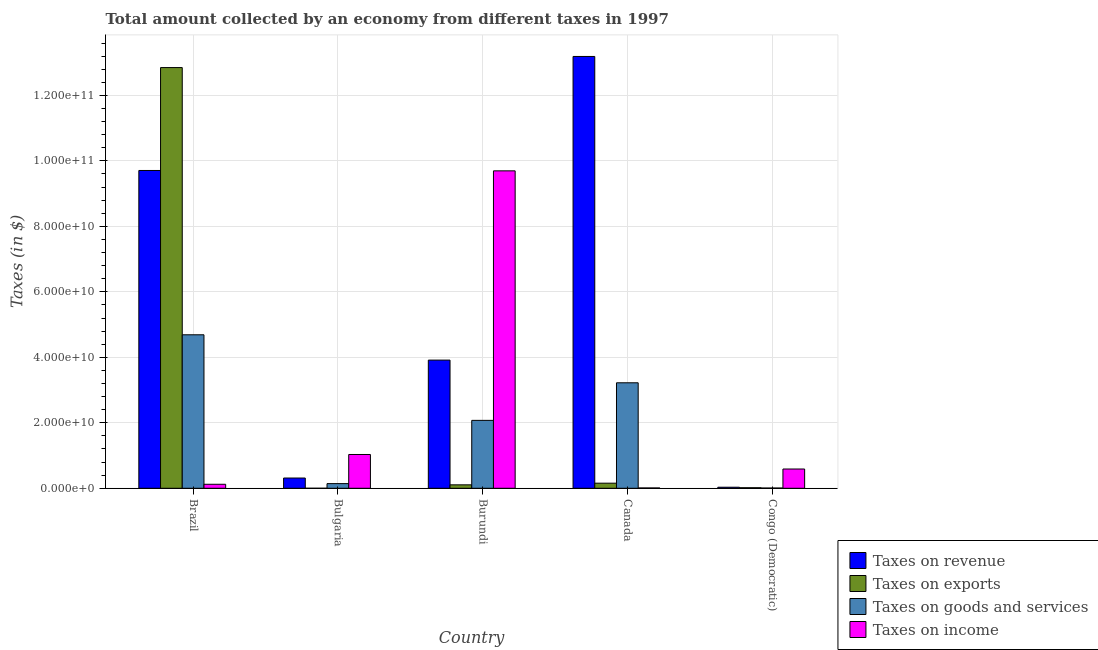How many different coloured bars are there?
Make the answer very short. 4. Are the number of bars per tick equal to the number of legend labels?
Your answer should be very brief. Yes. How many bars are there on the 4th tick from the right?
Your answer should be compact. 4. What is the label of the 5th group of bars from the left?
Offer a terse response. Congo (Democratic). What is the amount collected as tax on goods in Canada?
Offer a very short reply. 3.22e+1. Across all countries, what is the maximum amount collected as tax on revenue?
Your response must be concise. 1.32e+11. Across all countries, what is the minimum amount collected as tax on exports?
Make the answer very short. 2.00e+06. In which country was the amount collected as tax on goods minimum?
Offer a terse response. Congo (Democratic). What is the total amount collected as tax on goods in the graph?
Your answer should be compact. 1.01e+11. What is the difference between the amount collected as tax on goods in Bulgaria and that in Burundi?
Ensure brevity in your answer.  -1.93e+1. What is the difference between the amount collected as tax on exports in Canada and the amount collected as tax on revenue in Congo (Democratic)?
Offer a very short reply. 1.23e+09. What is the average amount collected as tax on goods per country?
Offer a terse response. 2.03e+1. What is the difference between the amount collected as tax on income and amount collected as tax on revenue in Bulgaria?
Ensure brevity in your answer.  7.19e+09. In how many countries, is the amount collected as tax on revenue greater than 124000000000 $?
Offer a terse response. 1. What is the ratio of the amount collected as tax on exports in Burundi to that in Congo (Democratic)?
Provide a short and direct response. 6.27. Is the amount collected as tax on goods in Brazil less than that in Congo (Democratic)?
Keep it short and to the point. No. What is the difference between the highest and the second highest amount collected as tax on revenue?
Provide a succinct answer. 3.48e+1. What is the difference between the highest and the lowest amount collected as tax on goods?
Keep it short and to the point. 4.68e+1. In how many countries, is the amount collected as tax on income greater than the average amount collected as tax on income taken over all countries?
Your answer should be very brief. 1. Is the sum of the amount collected as tax on income in Canada and Congo (Democratic) greater than the maximum amount collected as tax on goods across all countries?
Offer a very short reply. No. Is it the case that in every country, the sum of the amount collected as tax on revenue and amount collected as tax on goods is greater than the sum of amount collected as tax on exports and amount collected as tax on income?
Provide a succinct answer. No. What does the 2nd bar from the left in Canada represents?
Make the answer very short. Taxes on exports. What does the 3rd bar from the right in Bulgaria represents?
Make the answer very short. Taxes on exports. Is it the case that in every country, the sum of the amount collected as tax on revenue and amount collected as tax on exports is greater than the amount collected as tax on goods?
Your answer should be very brief. Yes. Does the graph contain any zero values?
Your answer should be compact. No. Does the graph contain grids?
Ensure brevity in your answer.  Yes. Where does the legend appear in the graph?
Keep it short and to the point. Bottom right. How many legend labels are there?
Your answer should be very brief. 4. What is the title of the graph?
Give a very brief answer. Total amount collected by an economy from different taxes in 1997. What is the label or title of the X-axis?
Keep it short and to the point. Country. What is the label or title of the Y-axis?
Your answer should be compact. Taxes (in $). What is the Taxes (in $) of Taxes on revenue in Brazil?
Offer a very short reply. 9.71e+1. What is the Taxes (in $) of Taxes on exports in Brazil?
Your answer should be very brief. 1.28e+11. What is the Taxes (in $) in Taxes on goods and services in Brazil?
Your response must be concise. 4.69e+1. What is the Taxes (in $) of Taxes on income in Brazil?
Make the answer very short. 1.22e+09. What is the Taxes (in $) of Taxes on revenue in Bulgaria?
Your response must be concise. 3.13e+09. What is the Taxes (in $) in Taxes on exports in Bulgaria?
Offer a very short reply. 2.00e+06. What is the Taxes (in $) of Taxes on goods and services in Bulgaria?
Give a very brief answer. 1.42e+09. What is the Taxes (in $) in Taxes on income in Bulgaria?
Your response must be concise. 1.03e+1. What is the Taxes (in $) of Taxes on revenue in Burundi?
Provide a short and direct response. 3.91e+1. What is the Taxes (in $) of Taxes on exports in Burundi?
Your answer should be compact. 1.05e+09. What is the Taxes (in $) of Taxes on goods and services in Burundi?
Offer a terse response. 2.07e+1. What is the Taxes (in $) of Taxes on income in Burundi?
Provide a short and direct response. 9.70e+1. What is the Taxes (in $) of Taxes on revenue in Canada?
Offer a terse response. 1.32e+11. What is the Taxes (in $) of Taxes on exports in Canada?
Make the answer very short. 1.56e+09. What is the Taxes (in $) in Taxes on goods and services in Canada?
Keep it short and to the point. 3.22e+1. What is the Taxes (in $) of Taxes on income in Canada?
Make the answer very short. 1.01e+08. What is the Taxes (in $) in Taxes on revenue in Congo (Democratic)?
Provide a short and direct response. 3.24e+08. What is the Taxes (in $) in Taxes on exports in Congo (Democratic)?
Make the answer very short. 1.68e+08. What is the Taxes (in $) in Taxes on goods and services in Congo (Democratic)?
Provide a succinct answer. 7.41e+07. What is the Taxes (in $) in Taxes on income in Congo (Democratic)?
Give a very brief answer. 5.89e+09. Across all countries, what is the maximum Taxes (in $) of Taxes on revenue?
Provide a short and direct response. 1.32e+11. Across all countries, what is the maximum Taxes (in $) of Taxes on exports?
Your answer should be very brief. 1.28e+11. Across all countries, what is the maximum Taxes (in $) in Taxes on goods and services?
Your answer should be compact. 4.69e+1. Across all countries, what is the maximum Taxes (in $) in Taxes on income?
Keep it short and to the point. 9.70e+1. Across all countries, what is the minimum Taxes (in $) of Taxes on revenue?
Make the answer very short. 3.24e+08. Across all countries, what is the minimum Taxes (in $) of Taxes on goods and services?
Offer a terse response. 7.41e+07. Across all countries, what is the minimum Taxes (in $) in Taxes on income?
Ensure brevity in your answer.  1.01e+08. What is the total Taxes (in $) in Taxes on revenue in the graph?
Make the answer very short. 2.72e+11. What is the total Taxes (in $) in Taxes on exports in the graph?
Offer a terse response. 1.31e+11. What is the total Taxes (in $) of Taxes on goods and services in the graph?
Keep it short and to the point. 1.01e+11. What is the total Taxes (in $) in Taxes on income in the graph?
Your response must be concise. 1.14e+11. What is the difference between the Taxes (in $) in Taxes on revenue in Brazil and that in Bulgaria?
Offer a very short reply. 9.39e+1. What is the difference between the Taxes (in $) of Taxes on exports in Brazil and that in Bulgaria?
Give a very brief answer. 1.28e+11. What is the difference between the Taxes (in $) in Taxes on goods and services in Brazil and that in Bulgaria?
Provide a short and direct response. 4.55e+1. What is the difference between the Taxes (in $) of Taxes on income in Brazil and that in Bulgaria?
Provide a succinct answer. -9.10e+09. What is the difference between the Taxes (in $) of Taxes on revenue in Brazil and that in Burundi?
Make the answer very short. 5.79e+1. What is the difference between the Taxes (in $) in Taxes on exports in Brazil and that in Burundi?
Give a very brief answer. 1.27e+11. What is the difference between the Taxes (in $) in Taxes on goods and services in Brazil and that in Burundi?
Keep it short and to the point. 2.61e+1. What is the difference between the Taxes (in $) of Taxes on income in Brazil and that in Burundi?
Give a very brief answer. -9.57e+1. What is the difference between the Taxes (in $) of Taxes on revenue in Brazil and that in Canada?
Offer a terse response. -3.48e+1. What is the difference between the Taxes (in $) of Taxes on exports in Brazil and that in Canada?
Your answer should be compact. 1.27e+11. What is the difference between the Taxes (in $) of Taxes on goods and services in Brazil and that in Canada?
Your response must be concise. 1.47e+1. What is the difference between the Taxes (in $) of Taxes on income in Brazil and that in Canada?
Give a very brief answer. 1.12e+09. What is the difference between the Taxes (in $) of Taxes on revenue in Brazil and that in Congo (Democratic)?
Make the answer very short. 9.67e+1. What is the difference between the Taxes (in $) in Taxes on exports in Brazil and that in Congo (Democratic)?
Offer a very short reply. 1.28e+11. What is the difference between the Taxes (in $) of Taxes on goods and services in Brazil and that in Congo (Democratic)?
Ensure brevity in your answer.  4.68e+1. What is the difference between the Taxes (in $) of Taxes on income in Brazil and that in Congo (Democratic)?
Provide a succinct answer. -4.67e+09. What is the difference between the Taxes (in $) of Taxes on revenue in Bulgaria and that in Burundi?
Provide a short and direct response. -3.60e+1. What is the difference between the Taxes (in $) in Taxes on exports in Bulgaria and that in Burundi?
Your response must be concise. -1.05e+09. What is the difference between the Taxes (in $) in Taxes on goods and services in Bulgaria and that in Burundi?
Provide a succinct answer. -1.93e+1. What is the difference between the Taxes (in $) of Taxes on income in Bulgaria and that in Burundi?
Provide a succinct answer. -8.66e+1. What is the difference between the Taxes (in $) in Taxes on revenue in Bulgaria and that in Canada?
Keep it short and to the point. -1.29e+11. What is the difference between the Taxes (in $) in Taxes on exports in Bulgaria and that in Canada?
Your response must be concise. -1.56e+09. What is the difference between the Taxes (in $) in Taxes on goods and services in Bulgaria and that in Canada?
Your response must be concise. -3.08e+1. What is the difference between the Taxes (in $) in Taxes on income in Bulgaria and that in Canada?
Provide a short and direct response. 1.02e+1. What is the difference between the Taxes (in $) of Taxes on revenue in Bulgaria and that in Congo (Democratic)?
Provide a succinct answer. 2.81e+09. What is the difference between the Taxes (in $) in Taxes on exports in Bulgaria and that in Congo (Democratic)?
Your answer should be very brief. -1.66e+08. What is the difference between the Taxes (in $) of Taxes on goods and services in Bulgaria and that in Congo (Democratic)?
Your answer should be compact. 1.35e+09. What is the difference between the Taxes (in $) of Taxes on income in Bulgaria and that in Congo (Democratic)?
Make the answer very short. 4.43e+09. What is the difference between the Taxes (in $) in Taxes on revenue in Burundi and that in Canada?
Your answer should be very brief. -9.27e+1. What is the difference between the Taxes (in $) in Taxes on exports in Burundi and that in Canada?
Your response must be concise. -5.06e+08. What is the difference between the Taxes (in $) in Taxes on goods and services in Burundi and that in Canada?
Your answer should be compact. -1.15e+1. What is the difference between the Taxes (in $) of Taxes on income in Burundi and that in Canada?
Your answer should be compact. 9.69e+1. What is the difference between the Taxes (in $) of Taxes on revenue in Burundi and that in Congo (Democratic)?
Keep it short and to the point. 3.88e+1. What is the difference between the Taxes (in $) of Taxes on exports in Burundi and that in Congo (Democratic)?
Offer a very short reply. 8.85e+08. What is the difference between the Taxes (in $) of Taxes on goods and services in Burundi and that in Congo (Democratic)?
Your answer should be compact. 2.07e+1. What is the difference between the Taxes (in $) in Taxes on income in Burundi and that in Congo (Democratic)?
Your answer should be very brief. 9.11e+1. What is the difference between the Taxes (in $) of Taxes on revenue in Canada and that in Congo (Democratic)?
Your answer should be compact. 1.32e+11. What is the difference between the Taxes (in $) of Taxes on exports in Canada and that in Congo (Democratic)?
Your answer should be very brief. 1.39e+09. What is the difference between the Taxes (in $) in Taxes on goods and services in Canada and that in Congo (Democratic)?
Offer a terse response. 3.21e+1. What is the difference between the Taxes (in $) in Taxes on income in Canada and that in Congo (Democratic)?
Give a very brief answer. -5.79e+09. What is the difference between the Taxes (in $) in Taxes on revenue in Brazil and the Taxes (in $) in Taxes on exports in Bulgaria?
Keep it short and to the point. 9.71e+1. What is the difference between the Taxes (in $) in Taxes on revenue in Brazil and the Taxes (in $) in Taxes on goods and services in Bulgaria?
Make the answer very short. 9.56e+1. What is the difference between the Taxes (in $) in Taxes on revenue in Brazil and the Taxes (in $) in Taxes on income in Bulgaria?
Your answer should be compact. 8.67e+1. What is the difference between the Taxes (in $) in Taxes on exports in Brazil and the Taxes (in $) in Taxes on goods and services in Bulgaria?
Offer a terse response. 1.27e+11. What is the difference between the Taxes (in $) in Taxes on exports in Brazil and the Taxes (in $) in Taxes on income in Bulgaria?
Make the answer very short. 1.18e+11. What is the difference between the Taxes (in $) in Taxes on goods and services in Brazil and the Taxes (in $) in Taxes on income in Bulgaria?
Keep it short and to the point. 3.66e+1. What is the difference between the Taxes (in $) in Taxes on revenue in Brazil and the Taxes (in $) in Taxes on exports in Burundi?
Offer a terse response. 9.60e+1. What is the difference between the Taxes (in $) of Taxes on revenue in Brazil and the Taxes (in $) of Taxes on goods and services in Burundi?
Your response must be concise. 7.63e+1. What is the difference between the Taxes (in $) in Taxes on revenue in Brazil and the Taxes (in $) in Taxes on income in Burundi?
Offer a terse response. 1.13e+08. What is the difference between the Taxes (in $) of Taxes on exports in Brazil and the Taxes (in $) of Taxes on goods and services in Burundi?
Provide a succinct answer. 1.08e+11. What is the difference between the Taxes (in $) in Taxes on exports in Brazil and the Taxes (in $) in Taxes on income in Burundi?
Your answer should be very brief. 3.15e+1. What is the difference between the Taxes (in $) of Taxes on goods and services in Brazil and the Taxes (in $) of Taxes on income in Burundi?
Your answer should be compact. -5.01e+1. What is the difference between the Taxes (in $) in Taxes on revenue in Brazil and the Taxes (in $) in Taxes on exports in Canada?
Ensure brevity in your answer.  9.55e+1. What is the difference between the Taxes (in $) in Taxes on revenue in Brazil and the Taxes (in $) in Taxes on goods and services in Canada?
Provide a short and direct response. 6.48e+1. What is the difference between the Taxes (in $) in Taxes on revenue in Brazil and the Taxes (in $) in Taxes on income in Canada?
Offer a very short reply. 9.70e+1. What is the difference between the Taxes (in $) in Taxes on exports in Brazil and the Taxes (in $) in Taxes on goods and services in Canada?
Keep it short and to the point. 9.63e+1. What is the difference between the Taxes (in $) in Taxes on exports in Brazil and the Taxes (in $) in Taxes on income in Canada?
Keep it short and to the point. 1.28e+11. What is the difference between the Taxes (in $) of Taxes on goods and services in Brazil and the Taxes (in $) of Taxes on income in Canada?
Your response must be concise. 4.68e+1. What is the difference between the Taxes (in $) in Taxes on revenue in Brazil and the Taxes (in $) in Taxes on exports in Congo (Democratic)?
Provide a short and direct response. 9.69e+1. What is the difference between the Taxes (in $) of Taxes on revenue in Brazil and the Taxes (in $) of Taxes on goods and services in Congo (Democratic)?
Give a very brief answer. 9.70e+1. What is the difference between the Taxes (in $) of Taxes on revenue in Brazil and the Taxes (in $) of Taxes on income in Congo (Democratic)?
Offer a terse response. 9.12e+1. What is the difference between the Taxes (in $) of Taxes on exports in Brazil and the Taxes (in $) of Taxes on goods and services in Congo (Democratic)?
Your response must be concise. 1.28e+11. What is the difference between the Taxes (in $) of Taxes on exports in Brazil and the Taxes (in $) of Taxes on income in Congo (Democratic)?
Keep it short and to the point. 1.23e+11. What is the difference between the Taxes (in $) in Taxes on goods and services in Brazil and the Taxes (in $) in Taxes on income in Congo (Democratic)?
Give a very brief answer. 4.10e+1. What is the difference between the Taxes (in $) in Taxes on revenue in Bulgaria and the Taxes (in $) in Taxes on exports in Burundi?
Your answer should be compact. 2.08e+09. What is the difference between the Taxes (in $) of Taxes on revenue in Bulgaria and the Taxes (in $) of Taxes on goods and services in Burundi?
Ensure brevity in your answer.  -1.76e+1. What is the difference between the Taxes (in $) of Taxes on revenue in Bulgaria and the Taxes (in $) of Taxes on income in Burundi?
Make the answer very short. -9.38e+1. What is the difference between the Taxes (in $) of Taxes on exports in Bulgaria and the Taxes (in $) of Taxes on goods and services in Burundi?
Provide a succinct answer. -2.07e+1. What is the difference between the Taxes (in $) of Taxes on exports in Bulgaria and the Taxes (in $) of Taxes on income in Burundi?
Ensure brevity in your answer.  -9.70e+1. What is the difference between the Taxes (in $) of Taxes on goods and services in Bulgaria and the Taxes (in $) of Taxes on income in Burundi?
Offer a very short reply. -9.55e+1. What is the difference between the Taxes (in $) in Taxes on revenue in Bulgaria and the Taxes (in $) in Taxes on exports in Canada?
Your answer should be very brief. 1.57e+09. What is the difference between the Taxes (in $) in Taxes on revenue in Bulgaria and the Taxes (in $) in Taxes on goods and services in Canada?
Provide a succinct answer. -2.91e+1. What is the difference between the Taxes (in $) in Taxes on revenue in Bulgaria and the Taxes (in $) in Taxes on income in Canada?
Your answer should be compact. 3.03e+09. What is the difference between the Taxes (in $) of Taxes on exports in Bulgaria and the Taxes (in $) of Taxes on goods and services in Canada?
Give a very brief answer. -3.22e+1. What is the difference between the Taxes (in $) of Taxes on exports in Bulgaria and the Taxes (in $) of Taxes on income in Canada?
Ensure brevity in your answer.  -9.87e+07. What is the difference between the Taxes (in $) in Taxes on goods and services in Bulgaria and the Taxes (in $) in Taxes on income in Canada?
Keep it short and to the point. 1.32e+09. What is the difference between the Taxes (in $) in Taxes on revenue in Bulgaria and the Taxes (in $) in Taxes on exports in Congo (Democratic)?
Your answer should be very brief. 2.96e+09. What is the difference between the Taxes (in $) in Taxes on revenue in Bulgaria and the Taxes (in $) in Taxes on goods and services in Congo (Democratic)?
Make the answer very short. 3.06e+09. What is the difference between the Taxes (in $) of Taxes on revenue in Bulgaria and the Taxes (in $) of Taxes on income in Congo (Democratic)?
Provide a succinct answer. -2.76e+09. What is the difference between the Taxes (in $) of Taxes on exports in Bulgaria and the Taxes (in $) of Taxes on goods and services in Congo (Democratic)?
Your response must be concise. -7.21e+07. What is the difference between the Taxes (in $) of Taxes on exports in Bulgaria and the Taxes (in $) of Taxes on income in Congo (Democratic)?
Ensure brevity in your answer.  -5.89e+09. What is the difference between the Taxes (in $) in Taxes on goods and services in Bulgaria and the Taxes (in $) in Taxes on income in Congo (Democratic)?
Provide a succinct answer. -4.46e+09. What is the difference between the Taxes (in $) in Taxes on revenue in Burundi and the Taxes (in $) in Taxes on exports in Canada?
Offer a terse response. 3.76e+1. What is the difference between the Taxes (in $) in Taxes on revenue in Burundi and the Taxes (in $) in Taxes on goods and services in Canada?
Give a very brief answer. 6.93e+09. What is the difference between the Taxes (in $) of Taxes on revenue in Burundi and the Taxes (in $) of Taxes on income in Canada?
Make the answer very short. 3.90e+1. What is the difference between the Taxes (in $) in Taxes on exports in Burundi and the Taxes (in $) in Taxes on goods and services in Canada?
Ensure brevity in your answer.  -3.12e+1. What is the difference between the Taxes (in $) of Taxes on exports in Burundi and the Taxes (in $) of Taxes on income in Canada?
Your answer should be compact. 9.52e+08. What is the difference between the Taxes (in $) of Taxes on goods and services in Burundi and the Taxes (in $) of Taxes on income in Canada?
Your answer should be compact. 2.06e+1. What is the difference between the Taxes (in $) of Taxes on revenue in Burundi and the Taxes (in $) of Taxes on exports in Congo (Democratic)?
Your response must be concise. 3.90e+1. What is the difference between the Taxes (in $) of Taxes on revenue in Burundi and the Taxes (in $) of Taxes on goods and services in Congo (Democratic)?
Offer a terse response. 3.91e+1. What is the difference between the Taxes (in $) in Taxes on revenue in Burundi and the Taxes (in $) in Taxes on income in Congo (Democratic)?
Provide a succinct answer. 3.33e+1. What is the difference between the Taxes (in $) in Taxes on exports in Burundi and the Taxes (in $) in Taxes on goods and services in Congo (Democratic)?
Your response must be concise. 9.79e+08. What is the difference between the Taxes (in $) in Taxes on exports in Burundi and the Taxes (in $) in Taxes on income in Congo (Democratic)?
Your answer should be very brief. -4.83e+09. What is the difference between the Taxes (in $) of Taxes on goods and services in Burundi and the Taxes (in $) of Taxes on income in Congo (Democratic)?
Make the answer very short. 1.49e+1. What is the difference between the Taxes (in $) of Taxes on revenue in Canada and the Taxes (in $) of Taxes on exports in Congo (Democratic)?
Your response must be concise. 1.32e+11. What is the difference between the Taxes (in $) in Taxes on revenue in Canada and the Taxes (in $) in Taxes on goods and services in Congo (Democratic)?
Your response must be concise. 1.32e+11. What is the difference between the Taxes (in $) of Taxes on revenue in Canada and the Taxes (in $) of Taxes on income in Congo (Democratic)?
Offer a very short reply. 1.26e+11. What is the difference between the Taxes (in $) of Taxes on exports in Canada and the Taxes (in $) of Taxes on goods and services in Congo (Democratic)?
Offer a very short reply. 1.48e+09. What is the difference between the Taxes (in $) in Taxes on exports in Canada and the Taxes (in $) in Taxes on income in Congo (Democratic)?
Your answer should be compact. -4.33e+09. What is the difference between the Taxes (in $) in Taxes on goods and services in Canada and the Taxes (in $) in Taxes on income in Congo (Democratic)?
Your response must be concise. 2.63e+1. What is the average Taxes (in $) in Taxes on revenue per country?
Provide a succinct answer. 5.43e+1. What is the average Taxes (in $) of Taxes on exports per country?
Ensure brevity in your answer.  2.63e+1. What is the average Taxes (in $) of Taxes on goods and services per country?
Provide a short and direct response. 2.03e+1. What is the average Taxes (in $) in Taxes on income per country?
Your response must be concise. 2.29e+1. What is the difference between the Taxes (in $) of Taxes on revenue and Taxes (in $) of Taxes on exports in Brazil?
Keep it short and to the point. -3.14e+1. What is the difference between the Taxes (in $) of Taxes on revenue and Taxes (in $) of Taxes on goods and services in Brazil?
Make the answer very short. 5.02e+1. What is the difference between the Taxes (in $) of Taxes on revenue and Taxes (in $) of Taxes on income in Brazil?
Offer a terse response. 9.58e+1. What is the difference between the Taxes (in $) of Taxes on exports and Taxes (in $) of Taxes on goods and services in Brazil?
Offer a terse response. 8.16e+1. What is the difference between the Taxes (in $) of Taxes on exports and Taxes (in $) of Taxes on income in Brazil?
Offer a very short reply. 1.27e+11. What is the difference between the Taxes (in $) in Taxes on goods and services and Taxes (in $) in Taxes on income in Brazil?
Keep it short and to the point. 4.57e+1. What is the difference between the Taxes (in $) of Taxes on revenue and Taxes (in $) of Taxes on exports in Bulgaria?
Your answer should be compact. 3.13e+09. What is the difference between the Taxes (in $) of Taxes on revenue and Taxes (in $) of Taxes on goods and services in Bulgaria?
Offer a very short reply. 1.71e+09. What is the difference between the Taxes (in $) of Taxes on revenue and Taxes (in $) of Taxes on income in Bulgaria?
Provide a short and direct response. -7.19e+09. What is the difference between the Taxes (in $) of Taxes on exports and Taxes (in $) of Taxes on goods and services in Bulgaria?
Ensure brevity in your answer.  -1.42e+09. What is the difference between the Taxes (in $) of Taxes on exports and Taxes (in $) of Taxes on income in Bulgaria?
Give a very brief answer. -1.03e+1. What is the difference between the Taxes (in $) in Taxes on goods and services and Taxes (in $) in Taxes on income in Bulgaria?
Provide a short and direct response. -8.90e+09. What is the difference between the Taxes (in $) of Taxes on revenue and Taxes (in $) of Taxes on exports in Burundi?
Make the answer very short. 3.81e+1. What is the difference between the Taxes (in $) in Taxes on revenue and Taxes (in $) in Taxes on goods and services in Burundi?
Provide a succinct answer. 1.84e+1. What is the difference between the Taxes (in $) in Taxes on revenue and Taxes (in $) in Taxes on income in Burundi?
Your answer should be compact. -5.78e+1. What is the difference between the Taxes (in $) in Taxes on exports and Taxes (in $) in Taxes on goods and services in Burundi?
Give a very brief answer. -1.97e+1. What is the difference between the Taxes (in $) in Taxes on exports and Taxes (in $) in Taxes on income in Burundi?
Your answer should be compact. -9.59e+1. What is the difference between the Taxes (in $) in Taxes on goods and services and Taxes (in $) in Taxes on income in Burundi?
Ensure brevity in your answer.  -7.62e+1. What is the difference between the Taxes (in $) of Taxes on revenue and Taxes (in $) of Taxes on exports in Canada?
Give a very brief answer. 1.30e+11. What is the difference between the Taxes (in $) of Taxes on revenue and Taxes (in $) of Taxes on goods and services in Canada?
Make the answer very short. 9.97e+1. What is the difference between the Taxes (in $) in Taxes on revenue and Taxes (in $) in Taxes on income in Canada?
Your response must be concise. 1.32e+11. What is the difference between the Taxes (in $) of Taxes on exports and Taxes (in $) of Taxes on goods and services in Canada?
Your answer should be very brief. -3.07e+1. What is the difference between the Taxes (in $) in Taxes on exports and Taxes (in $) in Taxes on income in Canada?
Offer a terse response. 1.46e+09. What is the difference between the Taxes (in $) of Taxes on goods and services and Taxes (in $) of Taxes on income in Canada?
Your answer should be compact. 3.21e+1. What is the difference between the Taxes (in $) in Taxes on revenue and Taxes (in $) in Taxes on exports in Congo (Democratic)?
Provide a short and direct response. 1.56e+08. What is the difference between the Taxes (in $) of Taxes on revenue and Taxes (in $) of Taxes on goods and services in Congo (Democratic)?
Offer a very short reply. 2.50e+08. What is the difference between the Taxes (in $) of Taxes on revenue and Taxes (in $) of Taxes on income in Congo (Democratic)?
Offer a terse response. -5.56e+09. What is the difference between the Taxes (in $) in Taxes on exports and Taxes (in $) in Taxes on goods and services in Congo (Democratic)?
Offer a very short reply. 9.39e+07. What is the difference between the Taxes (in $) of Taxes on exports and Taxes (in $) of Taxes on income in Congo (Democratic)?
Offer a very short reply. -5.72e+09. What is the difference between the Taxes (in $) of Taxes on goods and services and Taxes (in $) of Taxes on income in Congo (Democratic)?
Your response must be concise. -5.81e+09. What is the ratio of the Taxes (in $) in Taxes on revenue in Brazil to that in Bulgaria?
Keep it short and to the point. 30.99. What is the ratio of the Taxes (in $) of Taxes on exports in Brazil to that in Bulgaria?
Your answer should be compact. 6.42e+04. What is the ratio of the Taxes (in $) in Taxes on goods and services in Brazil to that in Bulgaria?
Offer a terse response. 32.92. What is the ratio of the Taxes (in $) in Taxes on income in Brazil to that in Bulgaria?
Ensure brevity in your answer.  0.12. What is the ratio of the Taxes (in $) in Taxes on revenue in Brazil to that in Burundi?
Your answer should be compact. 2.48. What is the ratio of the Taxes (in $) of Taxes on exports in Brazil to that in Burundi?
Provide a short and direct response. 122.03. What is the ratio of the Taxes (in $) in Taxes on goods and services in Brazil to that in Burundi?
Keep it short and to the point. 2.26. What is the ratio of the Taxes (in $) of Taxes on income in Brazil to that in Burundi?
Your answer should be very brief. 0.01. What is the ratio of the Taxes (in $) of Taxes on revenue in Brazil to that in Canada?
Ensure brevity in your answer.  0.74. What is the ratio of the Taxes (in $) in Taxes on exports in Brazil to that in Canada?
Your answer should be compact. 82.42. What is the ratio of the Taxes (in $) of Taxes on goods and services in Brazil to that in Canada?
Ensure brevity in your answer.  1.46. What is the ratio of the Taxes (in $) in Taxes on income in Brazil to that in Canada?
Ensure brevity in your answer.  12.14. What is the ratio of the Taxes (in $) in Taxes on revenue in Brazil to that in Congo (Democratic)?
Offer a terse response. 299.32. What is the ratio of the Taxes (in $) in Taxes on exports in Brazil to that in Congo (Democratic)?
Provide a short and direct response. 764.88. What is the ratio of the Taxes (in $) in Taxes on goods and services in Brazil to that in Congo (Democratic)?
Your response must be concise. 633.02. What is the ratio of the Taxes (in $) of Taxes on income in Brazil to that in Congo (Democratic)?
Offer a terse response. 0.21. What is the ratio of the Taxes (in $) in Taxes on exports in Bulgaria to that in Burundi?
Provide a succinct answer. 0. What is the ratio of the Taxes (in $) in Taxes on goods and services in Bulgaria to that in Burundi?
Keep it short and to the point. 0.07. What is the ratio of the Taxes (in $) in Taxes on income in Bulgaria to that in Burundi?
Offer a terse response. 0.11. What is the ratio of the Taxes (in $) of Taxes on revenue in Bulgaria to that in Canada?
Provide a short and direct response. 0.02. What is the ratio of the Taxes (in $) of Taxes on exports in Bulgaria to that in Canada?
Provide a short and direct response. 0. What is the ratio of the Taxes (in $) of Taxes on goods and services in Bulgaria to that in Canada?
Ensure brevity in your answer.  0.04. What is the ratio of the Taxes (in $) in Taxes on income in Bulgaria to that in Canada?
Your answer should be compact. 102.52. What is the ratio of the Taxes (in $) in Taxes on revenue in Bulgaria to that in Congo (Democratic)?
Provide a succinct answer. 9.66. What is the ratio of the Taxes (in $) of Taxes on exports in Bulgaria to that in Congo (Democratic)?
Your response must be concise. 0.01. What is the ratio of the Taxes (in $) of Taxes on goods and services in Bulgaria to that in Congo (Democratic)?
Provide a short and direct response. 19.23. What is the ratio of the Taxes (in $) of Taxes on income in Bulgaria to that in Congo (Democratic)?
Your answer should be compact. 1.75. What is the ratio of the Taxes (in $) in Taxes on revenue in Burundi to that in Canada?
Your answer should be very brief. 0.3. What is the ratio of the Taxes (in $) of Taxes on exports in Burundi to that in Canada?
Give a very brief answer. 0.68. What is the ratio of the Taxes (in $) in Taxes on goods and services in Burundi to that in Canada?
Offer a terse response. 0.64. What is the ratio of the Taxes (in $) of Taxes on income in Burundi to that in Canada?
Offer a terse response. 963.02. What is the ratio of the Taxes (in $) in Taxes on revenue in Burundi to that in Congo (Democratic)?
Provide a succinct answer. 120.72. What is the ratio of the Taxes (in $) in Taxes on exports in Burundi to that in Congo (Democratic)?
Give a very brief answer. 6.27. What is the ratio of the Taxes (in $) of Taxes on goods and services in Burundi to that in Congo (Democratic)?
Your response must be concise. 280.1. What is the ratio of the Taxes (in $) in Taxes on income in Burundi to that in Congo (Democratic)?
Keep it short and to the point. 16.47. What is the ratio of the Taxes (in $) in Taxes on revenue in Canada to that in Congo (Democratic)?
Provide a short and direct response. 406.7. What is the ratio of the Taxes (in $) of Taxes on exports in Canada to that in Congo (Democratic)?
Offer a very short reply. 9.28. What is the ratio of the Taxes (in $) in Taxes on goods and services in Canada to that in Congo (Democratic)?
Provide a succinct answer. 435.07. What is the ratio of the Taxes (in $) of Taxes on income in Canada to that in Congo (Democratic)?
Provide a short and direct response. 0.02. What is the difference between the highest and the second highest Taxes (in $) in Taxes on revenue?
Ensure brevity in your answer.  3.48e+1. What is the difference between the highest and the second highest Taxes (in $) in Taxes on exports?
Give a very brief answer. 1.27e+11. What is the difference between the highest and the second highest Taxes (in $) of Taxes on goods and services?
Your response must be concise. 1.47e+1. What is the difference between the highest and the second highest Taxes (in $) in Taxes on income?
Your answer should be very brief. 8.66e+1. What is the difference between the highest and the lowest Taxes (in $) in Taxes on revenue?
Give a very brief answer. 1.32e+11. What is the difference between the highest and the lowest Taxes (in $) of Taxes on exports?
Your response must be concise. 1.28e+11. What is the difference between the highest and the lowest Taxes (in $) in Taxes on goods and services?
Make the answer very short. 4.68e+1. What is the difference between the highest and the lowest Taxes (in $) of Taxes on income?
Ensure brevity in your answer.  9.69e+1. 